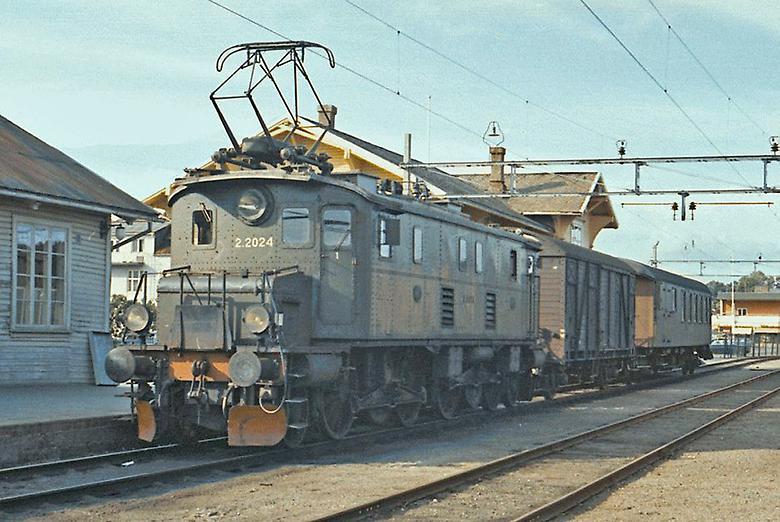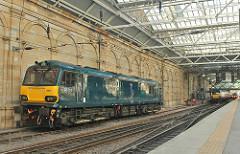The first image is the image on the left, the second image is the image on the right. Given the left and right images, does the statement "At least one electric pole is by a train track." hold true? Answer yes or no. No. The first image is the image on the left, the second image is the image on the right. For the images displayed, is the sentence "The train in both images is yellow and red." factually correct? Answer yes or no. No. 